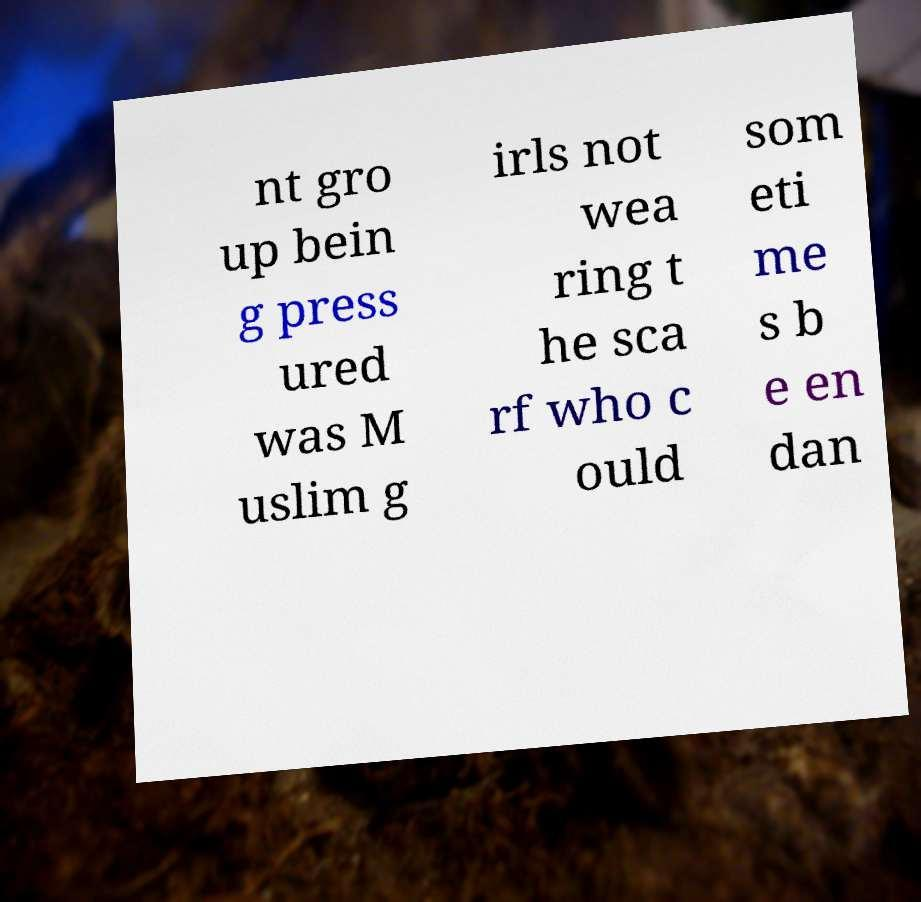There's text embedded in this image that I need extracted. Can you transcribe it verbatim? nt gro up bein g press ured was M uslim g irls not wea ring t he sca rf who c ould som eti me s b e en dan 